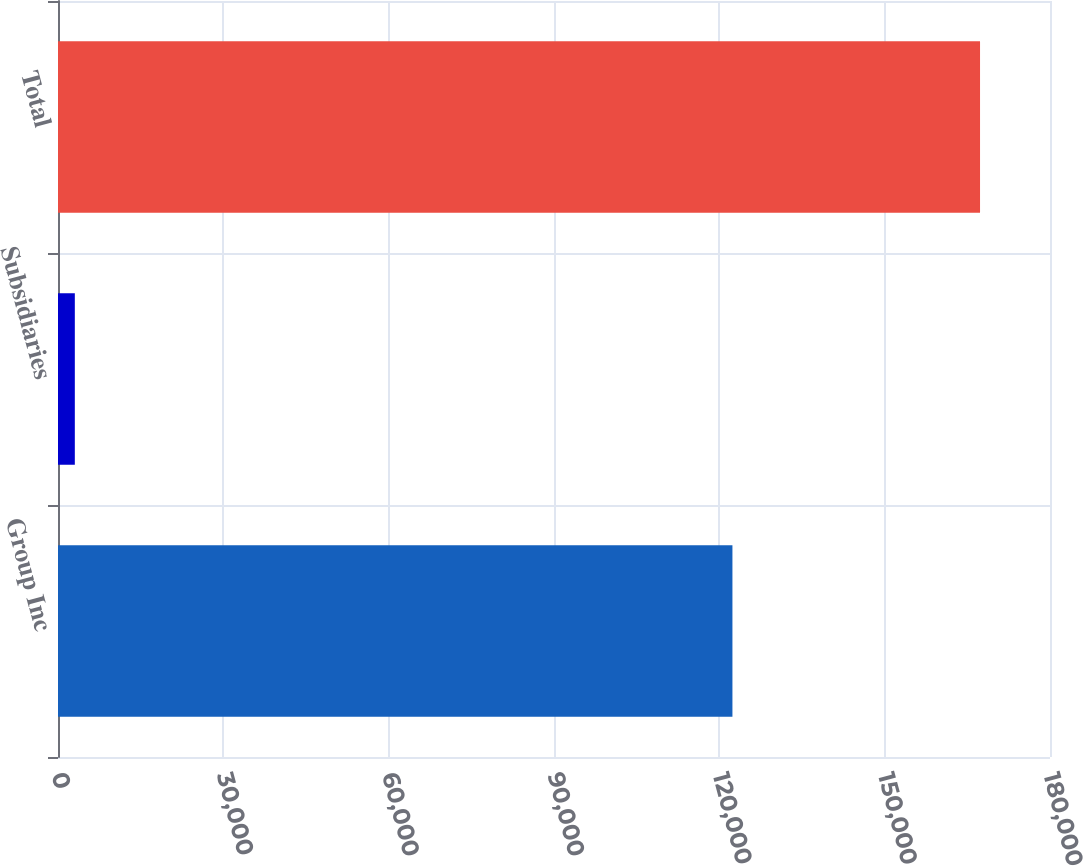Convert chart. <chart><loc_0><loc_0><loc_500><loc_500><bar_chart><fcel>Group Inc<fcel>Subsidiaries<fcel>Total<nl><fcel>122377<fcel>3053<fcel>167305<nl></chart> 